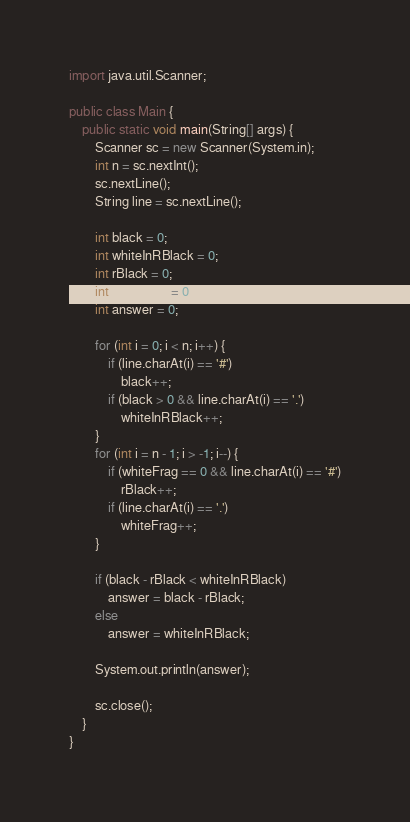<code> <loc_0><loc_0><loc_500><loc_500><_Java_>import java.util.Scanner;

public class Main {
	public static void main(String[] args) {
		Scanner sc = new Scanner(System.in);
		int n = sc.nextInt();
		sc.nextLine();
		String line = sc.nextLine();

		int black = 0;
		int whiteInRBlack = 0;
		int rBlack = 0;
		int whiteFrag = 0;
		int answer = 0;

		for (int i = 0; i < n; i++) {
			if (line.charAt(i) == '#')
				black++;
			if (black > 0 && line.charAt(i) == '.')
				whiteInRBlack++;
		}
		for (int i = n - 1; i > -1; i--) {
			if (whiteFrag == 0 && line.charAt(i) == '#')
				rBlack++;
			if (line.charAt(i) == '.')
				whiteFrag++;
		}

		if (black - rBlack < whiteInRBlack)
			answer = black - rBlack;
		else
			answer = whiteInRBlack;

		System.out.println(answer);

		sc.close();
	}
}</code> 